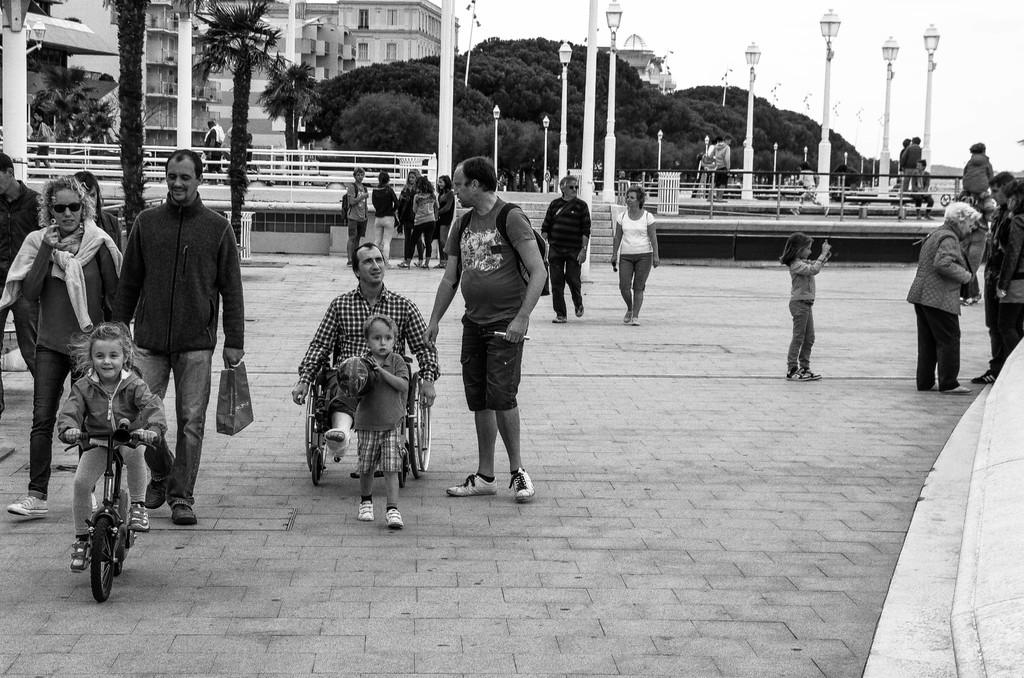What is happening in the image involving people? There is a group of people standing in the image. What activity is the girl in the image engaged in? The girl is riding a bicycle in the image. What can be seen in the background of the image? There are light poles, trees, buildings, and the sky visible in the background of the image. What type of oil is being used by the people in the image? There is no mention of oil in the image, and it is not a relevant detail to the scene depicted. What songs are the people in the image singing? There is no indication that the people in the image are singing, and no songs are mentioned or depicted. 